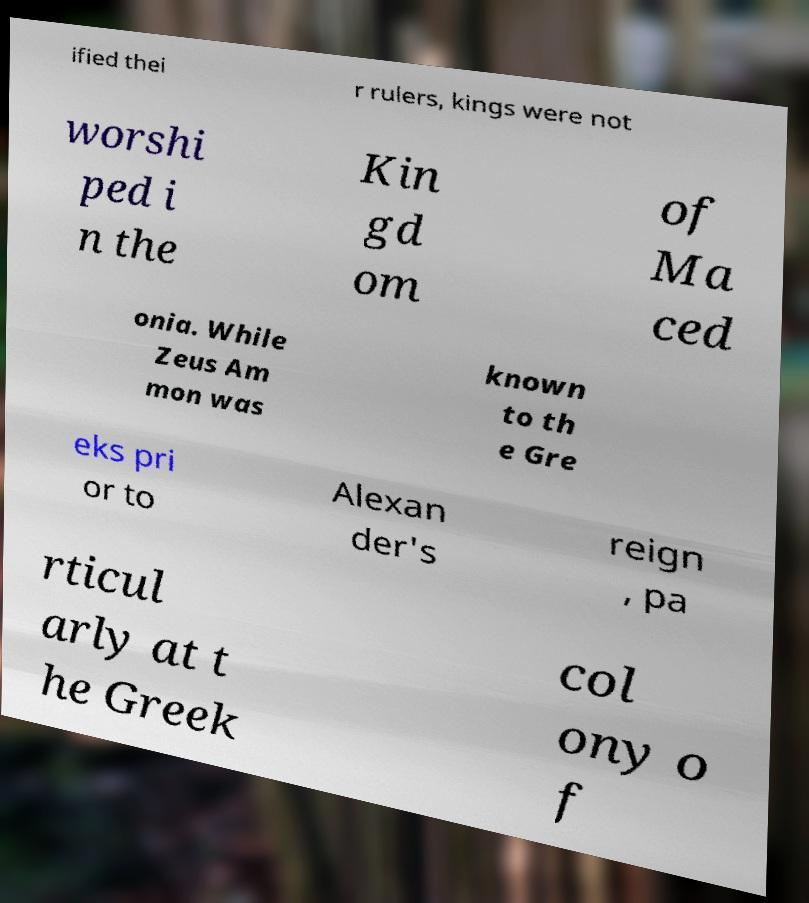Can you read and provide the text displayed in the image?This photo seems to have some interesting text. Can you extract and type it out for me? ified thei r rulers, kings were not worshi ped i n the Kin gd om of Ma ced onia. While Zeus Am mon was known to th e Gre eks pri or to Alexan der's reign , pa rticul arly at t he Greek col ony o f 